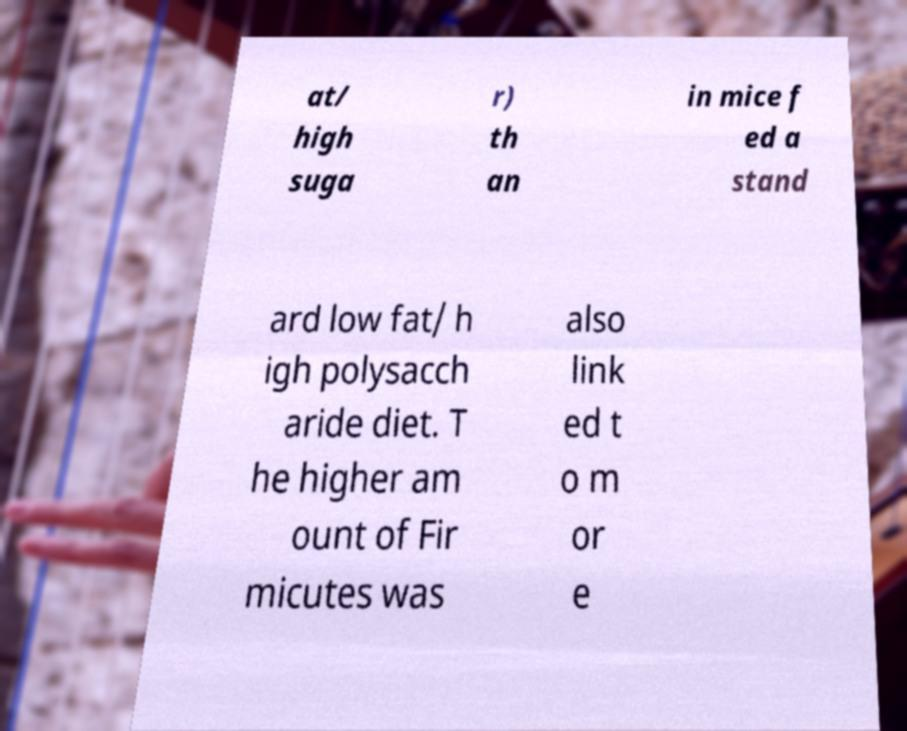There's text embedded in this image that I need extracted. Can you transcribe it verbatim? at/ high suga r) th an in mice f ed a stand ard low fat/ h igh polysacch aride diet. T he higher am ount of Fir micutes was also link ed t o m or e 